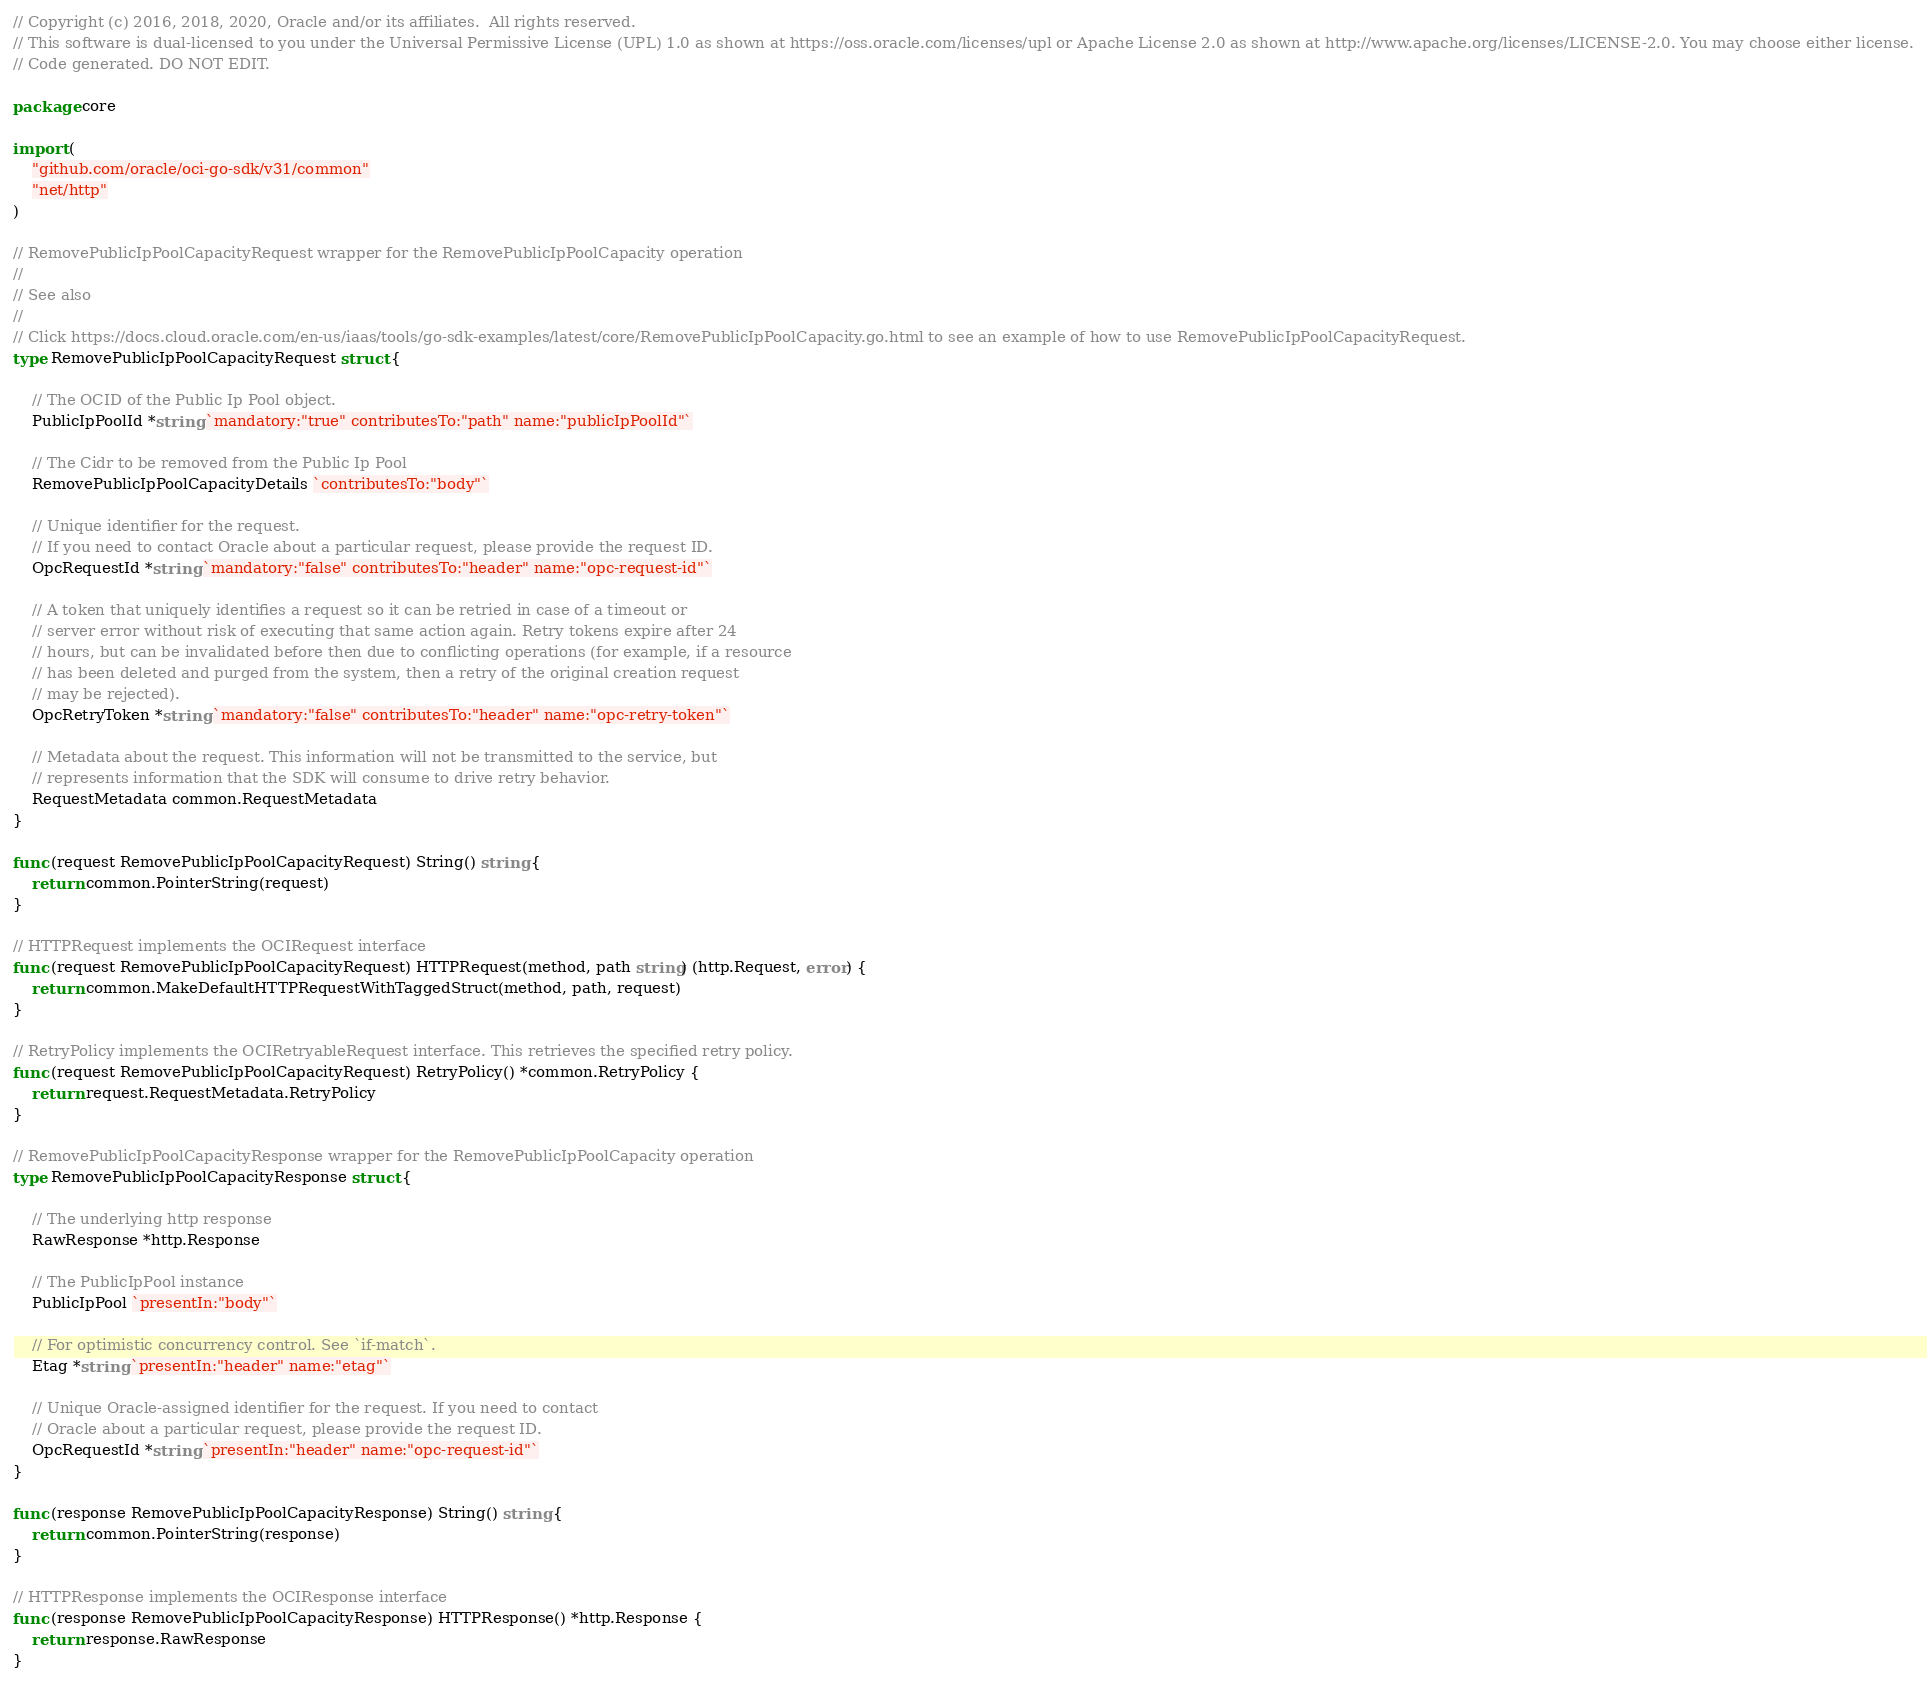<code> <loc_0><loc_0><loc_500><loc_500><_Go_>// Copyright (c) 2016, 2018, 2020, Oracle and/or its affiliates.  All rights reserved.
// This software is dual-licensed to you under the Universal Permissive License (UPL) 1.0 as shown at https://oss.oracle.com/licenses/upl or Apache License 2.0 as shown at http://www.apache.org/licenses/LICENSE-2.0. You may choose either license.
// Code generated. DO NOT EDIT.

package core

import (
	"github.com/oracle/oci-go-sdk/v31/common"
	"net/http"
)

// RemovePublicIpPoolCapacityRequest wrapper for the RemovePublicIpPoolCapacity operation
//
// See also
//
// Click https://docs.cloud.oracle.com/en-us/iaas/tools/go-sdk-examples/latest/core/RemovePublicIpPoolCapacity.go.html to see an example of how to use RemovePublicIpPoolCapacityRequest.
type RemovePublicIpPoolCapacityRequest struct {

	// The OCID of the Public Ip Pool object.
	PublicIpPoolId *string `mandatory:"true" contributesTo:"path" name:"publicIpPoolId"`

	// The Cidr to be removed from the Public Ip Pool
	RemovePublicIpPoolCapacityDetails `contributesTo:"body"`

	// Unique identifier for the request.
	// If you need to contact Oracle about a particular request, please provide the request ID.
	OpcRequestId *string `mandatory:"false" contributesTo:"header" name:"opc-request-id"`

	// A token that uniquely identifies a request so it can be retried in case of a timeout or
	// server error without risk of executing that same action again. Retry tokens expire after 24
	// hours, but can be invalidated before then due to conflicting operations (for example, if a resource
	// has been deleted and purged from the system, then a retry of the original creation request
	// may be rejected).
	OpcRetryToken *string `mandatory:"false" contributesTo:"header" name:"opc-retry-token"`

	// Metadata about the request. This information will not be transmitted to the service, but
	// represents information that the SDK will consume to drive retry behavior.
	RequestMetadata common.RequestMetadata
}

func (request RemovePublicIpPoolCapacityRequest) String() string {
	return common.PointerString(request)
}

// HTTPRequest implements the OCIRequest interface
func (request RemovePublicIpPoolCapacityRequest) HTTPRequest(method, path string) (http.Request, error) {
	return common.MakeDefaultHTTPRequestWithTaggedStruct(method, path, request)
}

// RetryPolicy implements the OCIRetryableRequest interface. This retrieves the specified retry policy.
func (request RemovePublicIpPoolCapacityRequest) RetryPolicy() *common.RetryPolicy {
	return request.RequestMetadata.RetryPolicy
}

// RemovePublicIpPoolCapacityResponse wrapper for the RemovePublicIpPoolCapacity operation
type RemovePublicIpPoolCapacityResponse struct {

	// The underlying http response
	RawResponse *http.Response

	// The PublicIpPool instance
	PublicIpPool `presentIn:"body"`

	// For optimistic concurrency control. See `if-match`.
	Etag *string `presentIn:"header" name:"etag"`

	// Unique Oracle-assigned identifier for the request. If you need to contact
	// Oracle about a particular request, please provide the request ID.
	OpcRequestId *string `presentIn:"header" name:"opc-request-id"`
}

func (response RemovePublicIpPoolCapacityResponse) String() string {
	return common.PointerString(response)
}

// HTTPResponse implements the OCIResponse interface
func (response RemovePublicIpPoolCapacityResponse) HTTPResponse() *http.Response {
	return response.RawResponse
}
</code> 